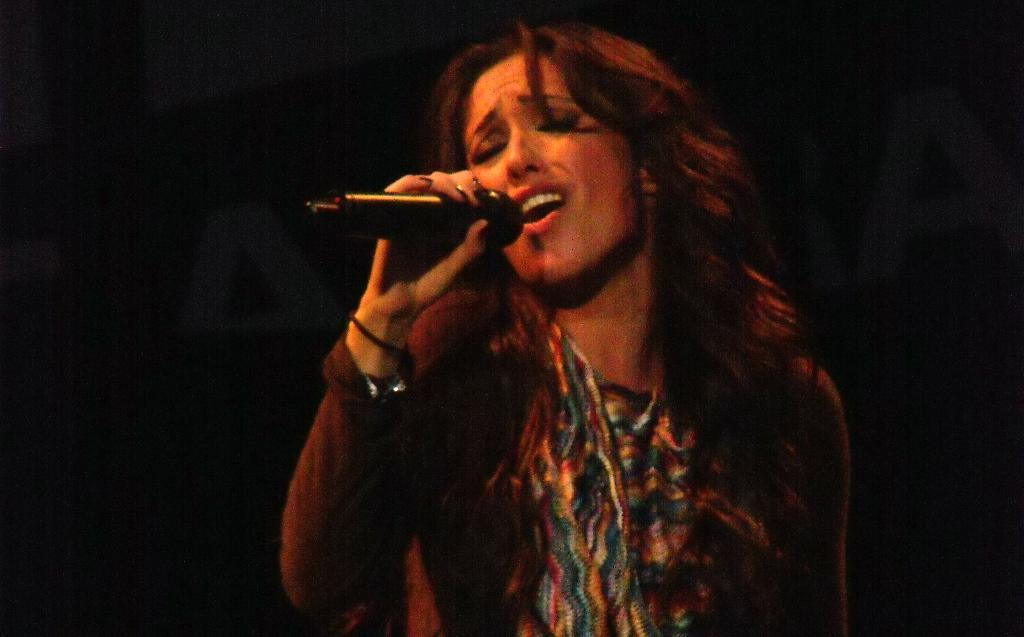What is the main subject of the image? The main subject of the image is a woman. What is the woman doing in the image? The woman is standing and singing into a microphone. Can you describe the microphone in the image? The microphone is black in color and is being held by the woman. What is the woman holding in her hand? The woman is holding a microphone. What type of porter is assisting the woman in the image? There is no porter present in the image. What color are the woman's lips in the image? The color of the woman's lips cannot be determined from the image. 